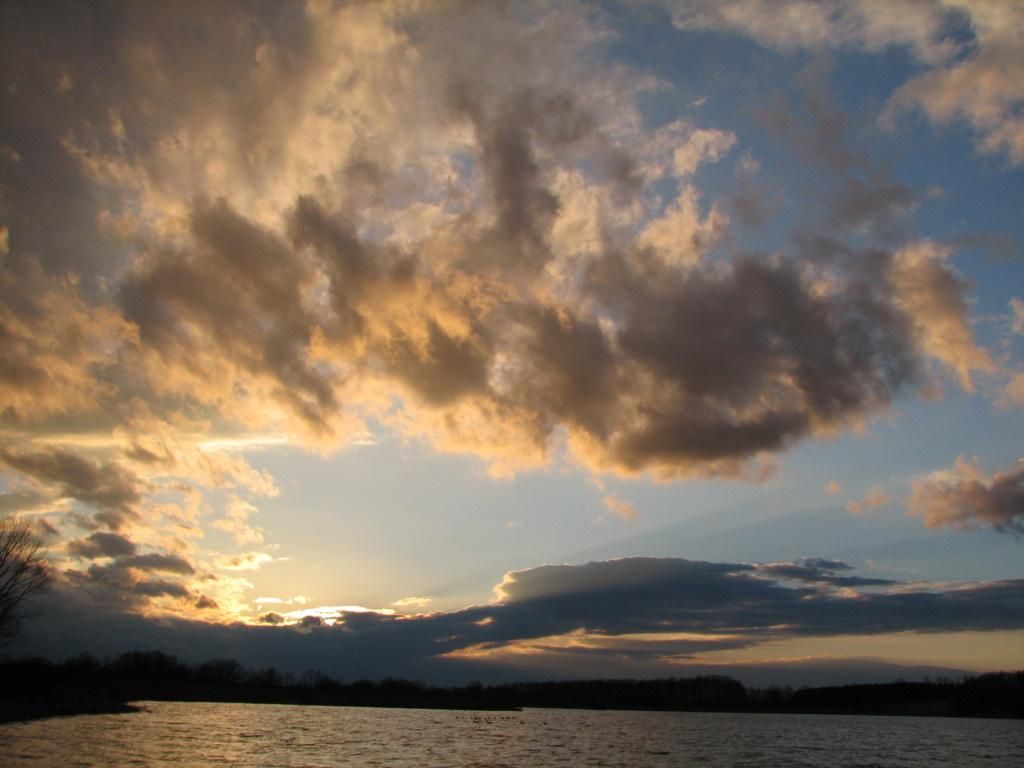What type of vegetation can be seen in the image? There are trees in the image. What can be seen in the sky at the top of the image? There are clouds in the sky at the top of the image. What is visible at the bottom of the image? There is water visible at the bottom of the image. Can you see a rifle hidden among the trees in the image? There is no rifle present in the image; it only features trees, clouds, and water. What type of cabbage is growing in the water at the bottom of the image? There is no cabbage present in the image; it only features trees, clouds, and water. 